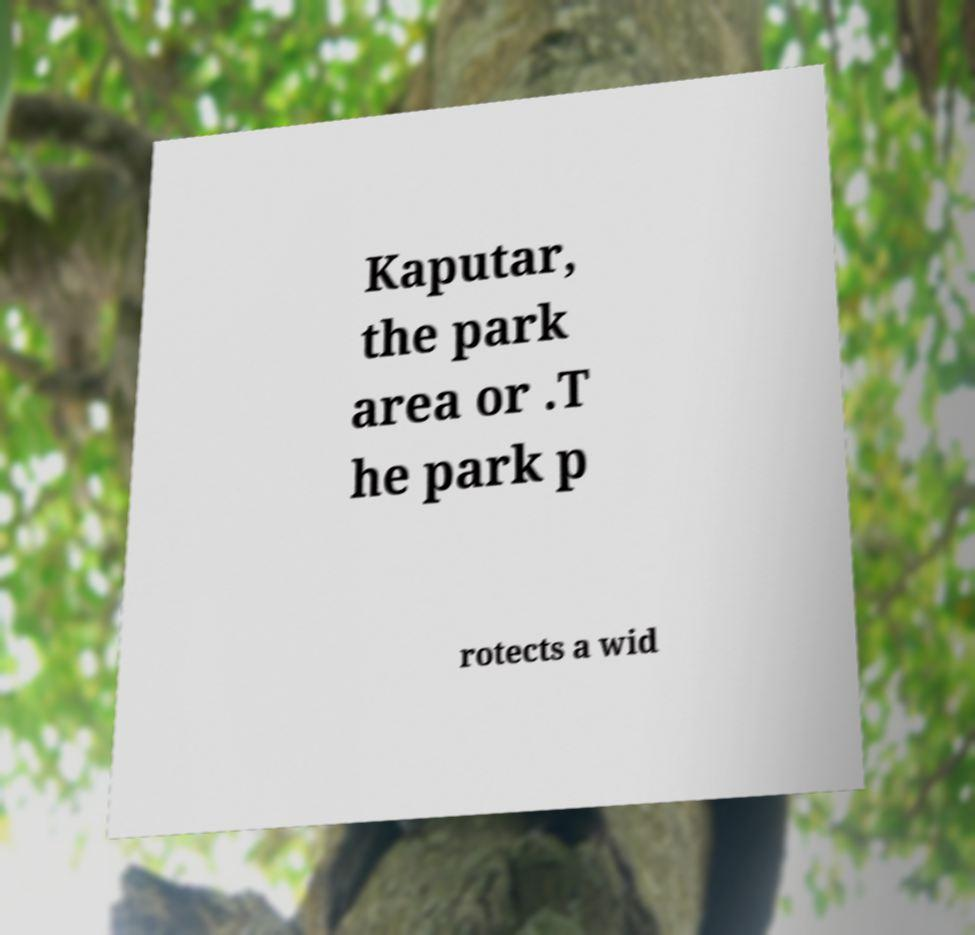Please identify and transcribe the text found in this image. Kaputar, the park area or .T he park p rotects a wid 